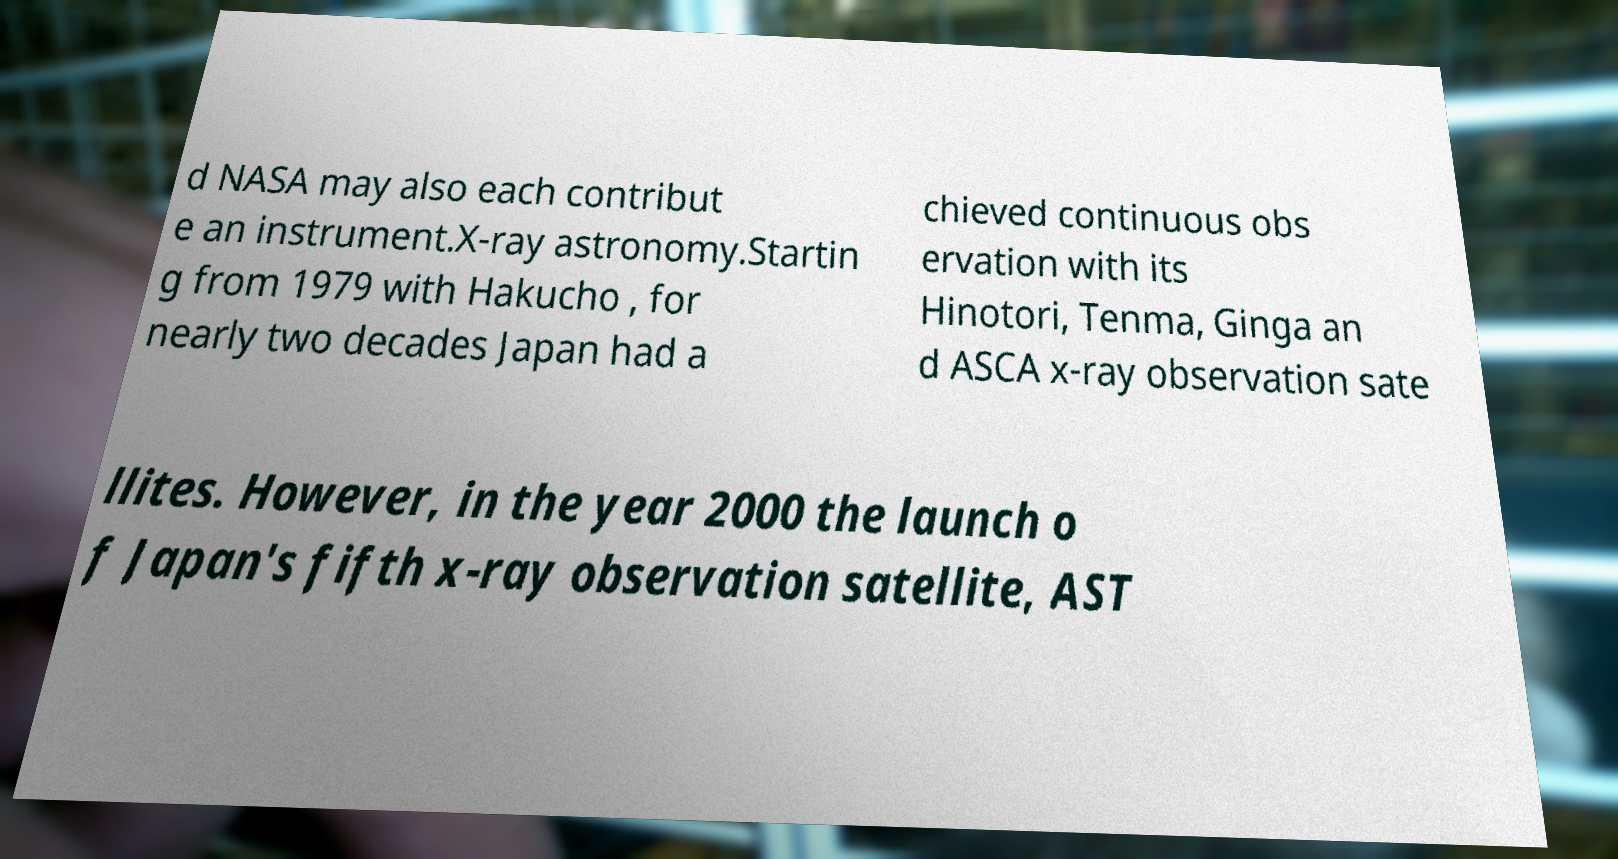Please identify and transcribe the text found in this image. d NASA may also each contribut e an instrument.X-ray astronomy.Startin g from 1979 with Hakucho , for nearly two decades Japan had a chieved continuous obs ervation with its Hinotori, Tenma, Ginga an d ASCA x-ray observation sate llites. However, in the year 2000 the launch o f Japan's fifth x-ray observation satellite, AST 